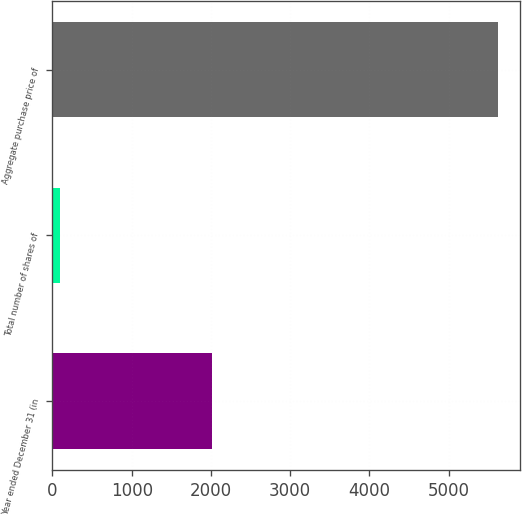<chart> <loc_0><loc_0><loc_500><loc_500><bar_chart><fcel>Year ended December 31 (in<fcel>Total number of shares of<fcel>Aggregate purchase price of<nl><fcel>2015<fcel>89.8<fcel>5616<nl></chart> 